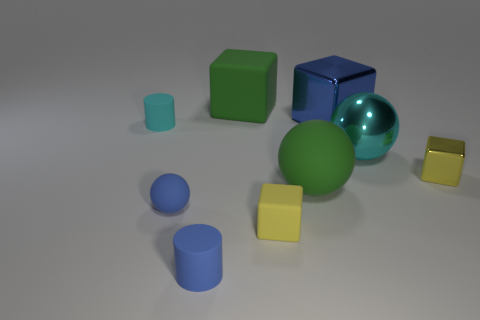Subtract all yellow metal cubes. How many cubes are left? 3 Subtract 2 blocks. How many blocks are left? 2 Subtract all red blocks. Subtract all green spheres. How many blocks are left? 4 Subtract all cylinders. How many objects are left? 7 Subtract 0 cyan cubes. How many objects are left? 9 Subtract all big green rubber cubes. Subtract all small yellow metal things. How many objects are left? 7 Add 6 tiny cyan matte cylinders. How many tiny cyan matte cylinders are left? 7 Add 1 large cyan balls. How many large cyan balls exist? 2 